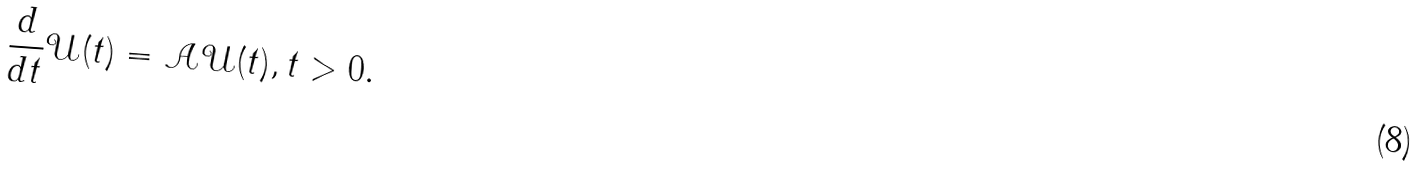<formula> <loc_0><loc_0><loc_500><loc_500>\frac { d } { d t } \mathcal { U } ( t ) = \mathcal { A } \mathcal { U } ( t ) , t > 0 .</formula> 